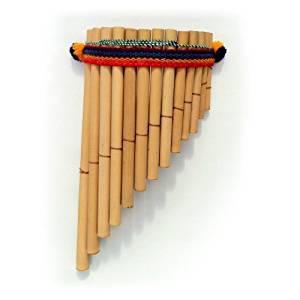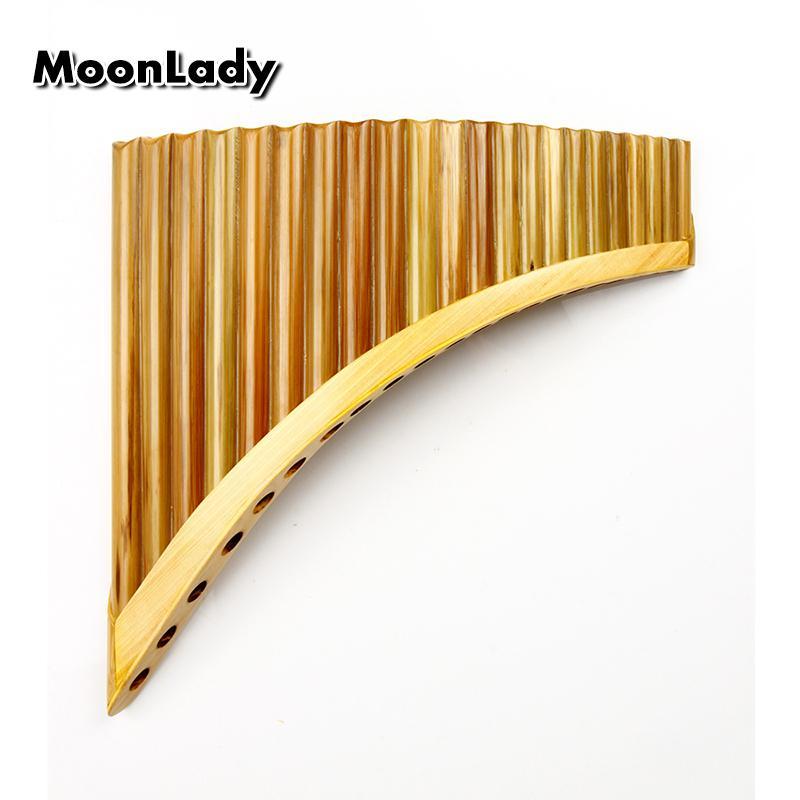The first image is the image on the left, the second image is the image on the right. Considering the images on both sides, is "Each instrument is curved." valid? Answer yes or no. No. The first image is the image on the left, the second image is the image on the right. Assess this claim about the two images: "Each image shows an instrument displayed with its aligned ends at the top, and its tallest 'tube' at the left.". Correct or not? Answer yes or no. Yes. 